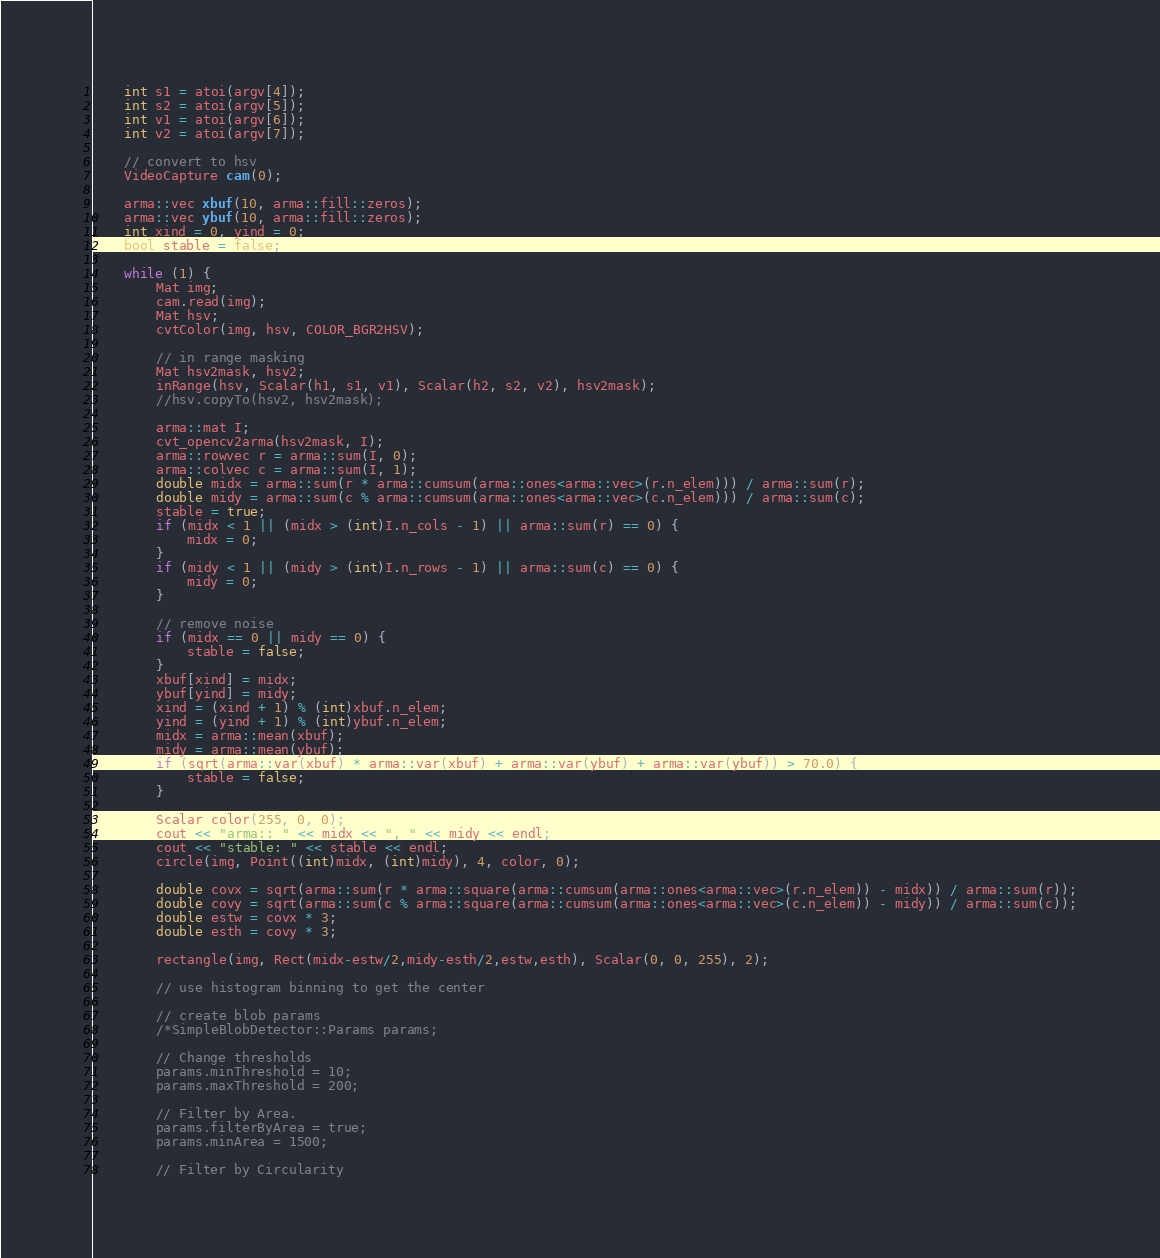<code> <loc_0><loc_0><loc_500><loc_500><_C++_>	int s1 = atoi(argv[4]);
	int s2 = atoi(argv[5]);
	int v1 = atoi(argv[6]);
	int v2 = atoi(argv[7]);

	// convert to hsv
	VideoCapture cam(0);

	arma::vec xbuf(10, arma::fill::zeros);
	arma::vec ybuf(10, arma::fill::zeros);
	int xind = 0, yind = 0;
	bool stable = false;

	while (1) {
		Mat img;
		cam.read(img);
		Mat hsv;
		cvtColor(img, hsv, COLOR_BGR2HSV);

		// in range masking
		Mat hsv2mask, hsv2;
		inRange(hsv, Scalar(h1, s1, v1), Scalar(h2, s2, v2), hsv2mask);
		//hsv.copyTo(hsv2, hsv2mask);

		arma::mat I;
		cvt_opencv2arma(hsv2mask, I);
		arma::rowvec r = arma::sum(I, 0);
		arma::colvec c = arma::sum(I, 1);
		double midx = arma::sum(r * arma::cumsum(arma::ones<arma::vec>(r.n_elem))) / arma::sum(r);
		double midy = arma::sum(c % arma::cumsum(arma::ones<arma::vec>(c.n_elem))) / arma::sum(c);
		stable = true;
		if (midx < 1 || (midx > (int)I.n_cols - 1) || arma::sum(r) == 0) {
			midx = 0;
		}
		if (midy < 1 || (midy > (int)I.n_rows - 1) || arma::sum(c) == 0) {
			midy = 0;
		}

		// remove noise
		if (midx == 0 || midy == 0) {
			stable = false;
		}
		xbuf[xind] = midx;
		ybuf[yind] = midy;
		xind = (xind + 1) % (int)xbuf.n_elem;
		yind = (yind + 1) % (int)ybuf.n_elem;
		midx = arma::mean(xbuf);
		midy = arma::mean(ybuf);
		if (sqrt(arma::var(xbuf) * arma::var(xbuf) + arma::var(ybuf) + arma::var(ybuf)) > 70.0) {
			stable = false;
		}
		
		Scalar color(255, 0, 0);
		cout << "arma:: " << midx << ", " << midy << endl;
		cout << "stable: " << stable << endl;
		circle(img, Point((int)midx, (int)midy), 4, color, 0);

		double covx = sqrt(arma::sum(r * arma::square(arma::cumsum(arma::ones<arma::vec>(r.n_elem)) - midx)) / arma::sum(r));
		double covy = sqrt(arma::sum(c % arma::square(arma::cumsum(arma::ones<arma::vec>(c.n_elem)) - midy)) / arma::sum(c));
		double estw = covx * 3;
		double esth = covy * 3;

		rectangle(img, Rect(midx-estw/2,midy-esth/2,estw,esth), Scalar(0, 0, 255), 2);

		// use histogram binning to get the center

		// create blob params
		/*SimpleBlobDetector::Params params;

		// Change thresholds
		params.minThreshold = 10;
		params.maxThreshold = 200;

		// Filter by Area.
		params.filterByArea = true;
		params.minArea = 1500;

		// Filter by Circularity</code> 